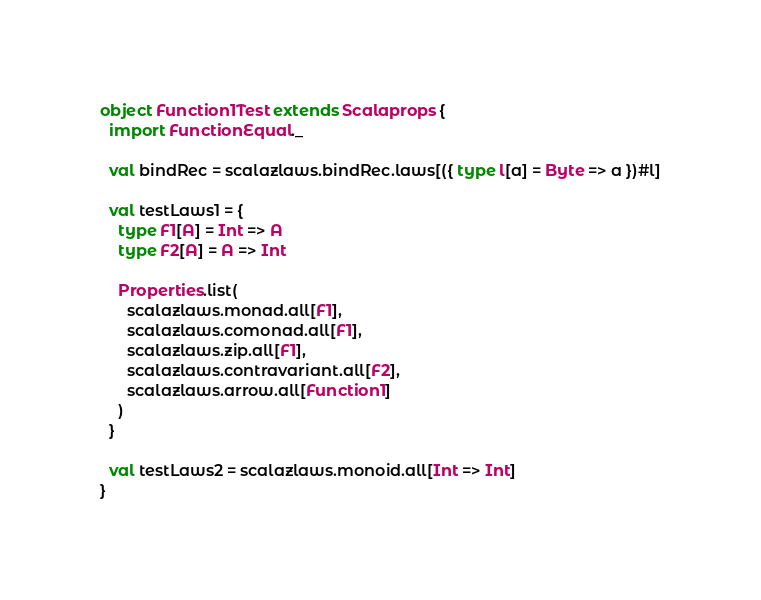<code> <loc_0><loc_0><loc_500><loc_500><_Scala_>object Function1Test extends Scalaprops {
  import FunctionEqual._

  val bindRec = scalazlaws.bindRec.laws[({ type l[a] = Byte => a })#l]

  val testLaws1 = {
    type F1[A] = Int => A
    type F2[A] = A => Int

    Properties.list(
      scalazlaws.monad.all[F1],
      scalazlaws.comonad.all[F1],
      scalazlaws.zip.all[F1],
      scalazlaws.contravariant.all[F2],
      scalazlaws.arrow.all[Function1]
    )
  }

  val testLaws2 = scalazlaws.monoid.all[Int => Int]
}
</code> 